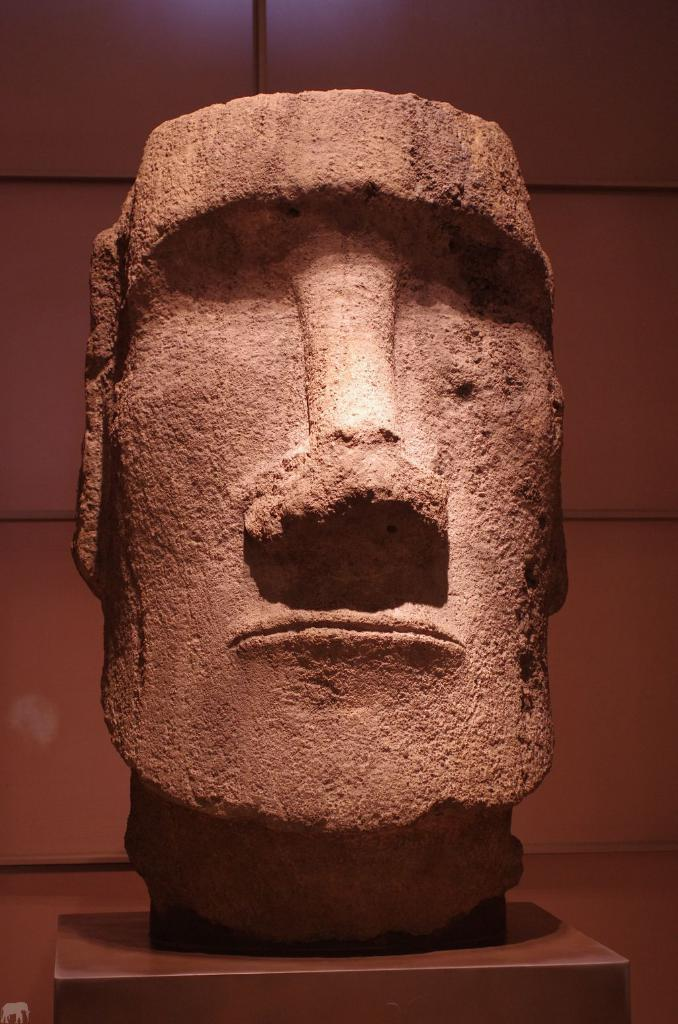What is the main subject of the image? The main subject of the image is a statue. Can you describe the statue in the image? The statue is of a human face. How many ducks are pushing the statue in the image? There are no ducks present in the image, and therefore no such activity can be observed. What type of animal is depicted on the statue in the image? The statue in the image is of a human face, not an animal like a tiger. 